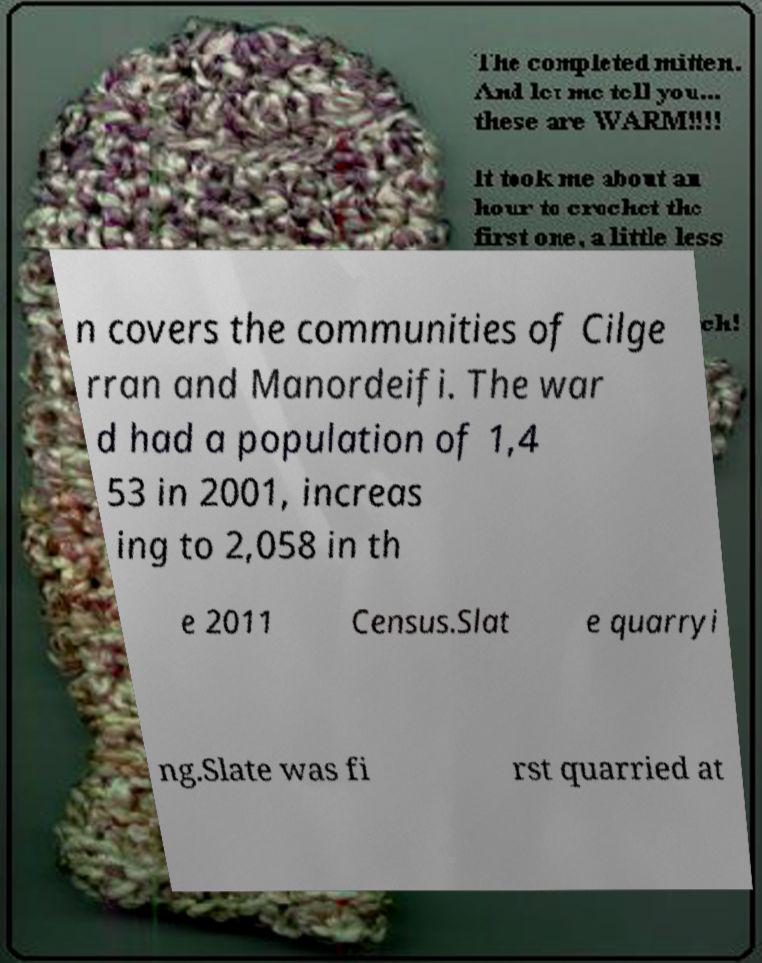Please read and relay the text visible in this image. What does it say? n covers the communities of Cilge rran and Manordeifi. The war d had a population of 1,4 53 in 2001, increas ing to 2,058 in th e 2011 Census.Slat e quarryi ng.Slate was fi rst quarried at 